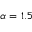<formula> <loc_0><loc_0><loc_500><loc_500>\alpha = 1 . 5</formula> 